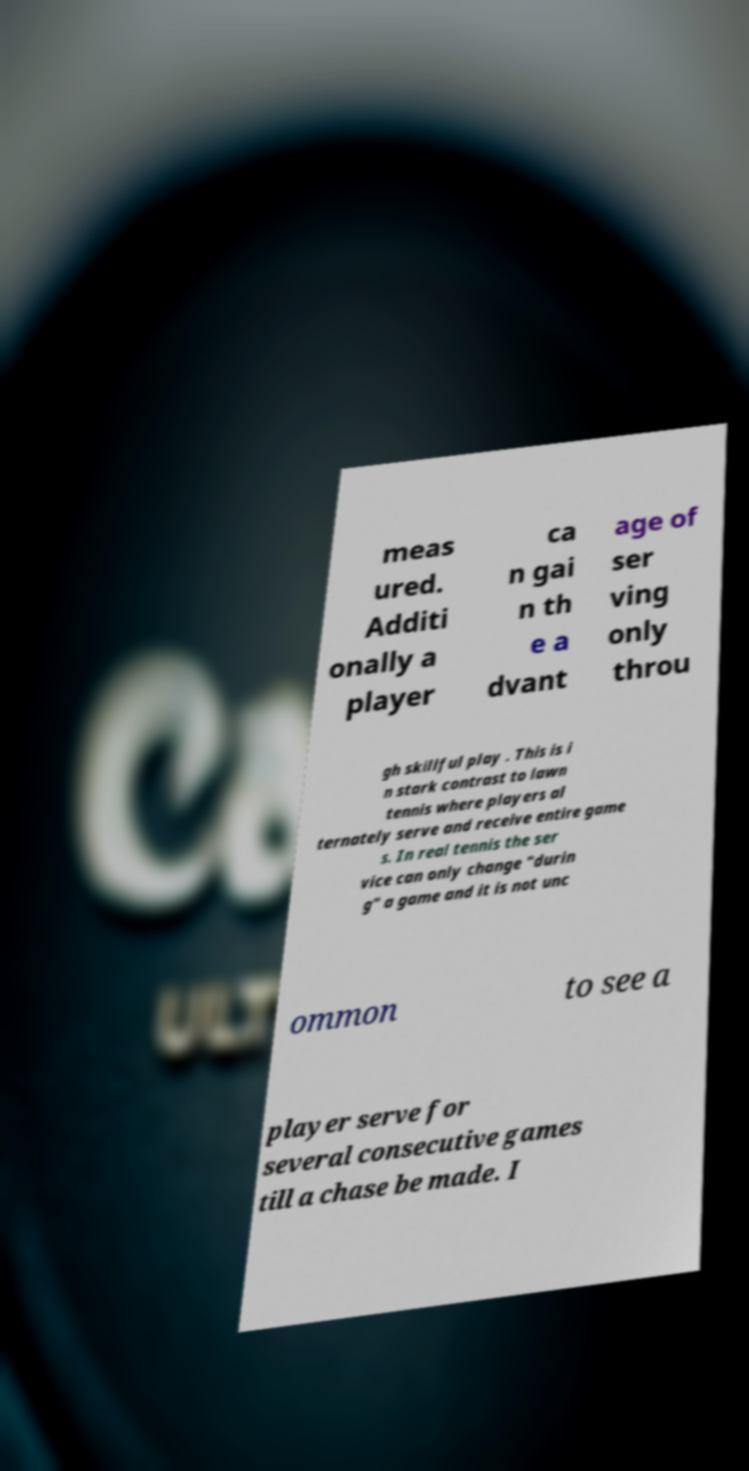There's text embedded in this image that I need extracted. Can you transcribe it verbatim? meas ured. Additi onally a player ca n gai n th e a dvant age of ser ving only throu gh skillful play . This is i n stark contrast to lawn tennis where players al ternately serve and receive entire game s. In real tennis the ser vice can only change "durin g" a game and it is not unc ommon to see a player serve for several consecutive games till a chase be made. I 